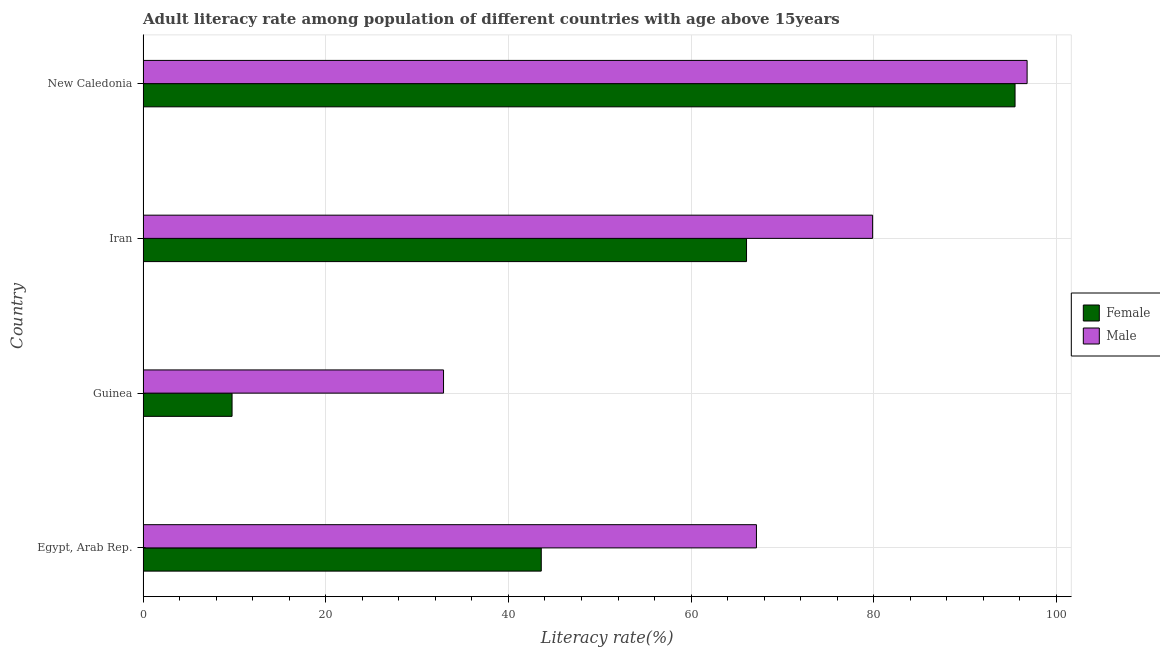How many different coloured bars are there?
Offer a terse response. 2. How many groups of bars are there?
Provide a short and direct response. 4. Are the number of bars on each tick of the Y-axis equal?
Your response must be concise. Yes. What is the label of the 1st group of bars from the top?
Offer a terse response. New Caledonia. What is the female adult literacy rate in Egypt, Arab Rep.?
Provide a succinct answer. 43.6. Across all countries, what is the maximum female adult literacy rate?
Offer a terse response. 95.47. Across all countries, what is the minimum female adult literacy rate?
Your answer should be compact. 9.74. In which country was the female adult literacy rate maximum?
Keep it short and to the point. New Caledonia. In which country was the female adult literacy rate minimum?
Provide a short and direct response. Guinea. What is the total female adult literacy rate in the graph?
Your response must be concise. 214.87. What is the difference between the male adult literacy rate in Guinea and that in New Caledonia?
Provide a succinct answer. -63.89. What is the difference between the male adult literacy rate in Iran and the female adult literacy rate in New Caledonia?
Ensure brevity in your answer.  -15.59. What is the average female adult literacy rate per country?
Your response must be concise. 53.72. What is the difference between the female adult literacy rate and male adult literacy rate in Guinea?
Offer a very short reply. -23.15. What is the ratio of the female adult literacy rate in Egypt, Arab Rep. to that in New Caledonia?
Provide a short and direct response. 0.46. Is the difference between the male adult literacy rate in Guinea and New Caledonia greater than the difference between the female adult literacy rate in Guinea and New Caledonia?
Offer a terse response. Yes. What is the difference between the highest and the second highest male adult literacy rate?
Offer a terse response. 16.91. What is the difference between the highest and the lowest male adult literacy rate?
Make the answer very short. 63.89. In how many countries, is the male adult literacy rate greater than the average male adult literacy rate taken over all countries?
Your answer should be compact. 2. What does the 1st bar from the top in Guinea represents?
Your answer should be compact. Male. How many bars are there?
Ensure brevity in your answer.  8. What is the difference between two consecutive major ticks on the X-axis?
Your response must be concise. 20. Does the graph contain any zero values?
Ensure brevity in your answer.  No. Does the graph contain grids?
Your response must be concise. Yes. What is the title of the graph?
Your response must be concise. Adult literacy rate among population of different countries with age above 15years. What is the label or title of the X-axis?
Offer a terse response. Literacy rate(%). What is the Literacy rate(%) in Female in Egypt, Arab Rep.?
Offer a terse response. 43.6. What is the Literacy rate(%) of Male in Egypt, Arab Rep.?
Keep it short and to the point. 67.15. What is the Literacy rate(%) of Female in Guinea?
Offer a very short reply. 9.74. What is the Literacy rate(%) of Male in Guinea?
Provide a succinct answer. 32.9. What is the Literacy rate(%) in Female in Iran?
Your answer should be very brief. 66.07. What is the Literacy rate(%) in Male in Iran?
Give a very brief answer. 79.87. What is the Literacy rate(%) in Female in New Caledonia?
Give a very brief answer. 95.47. What is the Literacy rate(%) in Male in New Caledonia?
Provide a succinct answer. 96.78. Across all countries, what is the maximum Literacy rate(%) in Female?
Your response must be concise. 95.47. Across all countries, what is the maximum Literacy rate(%) in Male?
Ensure brevity in your answer.  96.78. Across all countries, what is the minimum Literacy rate(%) of Female?
Provide a short and direct response. 9.74. Across all countries, what is the minimum Literacy rate(%) of Male?
Provide a succinct answer. 32.9. What is the total Literacy rate(%) of Female in the graph?
Offer a very short reply. 214.87. What is the total Literacy rate(%) of Male in the graph?
Offer a very short reply. 276.7. What is the difference between the Literacy rate(%) of Female in Egypt, Arab Rep. and that in Guinea?
Offer a very short reply. 33.85. What is the difference between the Literacy rate(%) in Male in Egypt, Arab Rep. and that in Guinea?
Your response must be concise. 34.26. What is the difference between the Literacy rate(%) of Female in Egypt, Arab Rep. and that in Iran?
Give a very brief answer. -22.47. What is the difference between the Literacy rate(%) in Male in Egypt, Arab Rep. and that in Iran?
Provide a short and direct response. -12.72. What is the difference between the Literacy rate(%) in Female in Egypt, Arab Rep. and that in New Caledonia?
Ensure brevity in your answer.  -51.87. What is the difference between the Literacy rate(%) in Male in Egypt, Arab Rep. and that in New Caledonia?
Make the answer very short. -29.63. What is the difference between the Literacy rate(%) of Female in Guinea and that in Iran?
Provide a succinct answer. -56.32. What is the difference between the Literacy rate(%) in Male in Guinea and that in Iran?
Keep it short and to the point. -46.98. What is the difference between the Literacy rate(%) in Female in Guinea and that in New Caledonia?
Give a very brief answer. -85.72. What is the difference between the Literacy rate(%) in Male in Guinea and that in New Caledonia?
Provide a succinct answer. -63.89. What is the difference between the Literacy rate(%) in Female in Iran and that in New Caledonia?
Provide a short and direct response. -29.4. What is the difference between the Literacy rate(%) in Male in Iran and that in New Caledonia?
Your answer should be very brief. -16.91. What is the difference between the Literacy rate(%) in Female in Egypt, Arab Rep. and the Literacy rate(%) in Male in Guinea?
Make the answer very short. 10.7. What is the difference between the Literacy rate(%) of Female in Egypt, Arab Rep. and the Literacy rate(%) of Male in Iran?
Offer a terse response. -36.28. What is the difference between the Literacy rate(%) of Female in Egypt, Arab Rep. and the Literacy rate(%) of Male in New Caledonia?
Ensure brevity in your answer.  -53.19. What is the difference between the Literacy rate(%) in Female in Guinea and the Literacy rate(%) in Male in Iran?
Give a very brief answer. -70.13. What is the difference between the Literacy rate(%) in Female in Guinea and the Literacy rate(%) in Male in New Caledonia?
Give a very brief answer. -87.04. What is the difference between the Literacy rate(%) in Female in Iran and the Literacy rate(%) in Male in New Caledonia?
Give a very brief answer. -30.72. What is the average Literacy rate(%) in Female per country?
Offer a terse response. 53.72. What is the average Literacy rate(%) of Male per country?
Your answer should be compact. 69.18. What is the difference between the Literacy rate(%) of Female and Literacy rate(%) of Male in Egypt, Arab Rep.?
Your answer should be compact. -23.56. What is the difference between the Literacy rate(%) of Female and Literacy rate(%) of Male in Guinea?
Your answer should be compact. -23.15. What is the difference between the Literacy rate(%) of Female and Literacy rate(%) of Male in Iran?
Offer a terse response. -13.8. What is the difference between the Literacy rate(%) in Female and Literacy rate(%) in Male in New Caledonia?
Offer a very short reply. -1.32. What is the ratio of the Literacy rate(%) of Female in Egypt, Arab Rep. to that in Guinea?
Give a very brief answer. 4.47. What is the ratio of the Literacy rate(%) in Male in Egypt, Arab Rep. to that in Guinea?
Make the answer very short. 2.04. What is the ratio of the Literacy rate(%) of Female in Egypt, Arab Rep. to that in Iran?
Offer a very short reply. 0.66. What is the ratio of the Literacy rate(%) in Male in Egypt, Arab Rep. to that in Iran?
Make the answer very short. 0.84. What is the ratio of the Literacy rate(%) in Female in Egypt, Arab Rep. to that in New Caledonia?
Your answer should be compact. 0.46. What is the ratio of the Literacy rate(%) in Male in Egypt, Arab Rep. to that in New Caledonia?
Keep it short and to the point. 0.69. What is the ratio of the Literacy rate(%) of Female in Guinea to that in Iran?
Ensure brevity in your answer.  0.15. What is the ratio of the Literacy rate(%) of Male in Guinea to that in Iran?
Give a very brief answer. 0.41. What is the ratio of the Literacy rate(%) of Female in Guinea to that in New Caledonia?
Your answer should be very brief. 0.1. What is the ratio of the Literacy rate(%) in Male in Guinea to that in New Caledonia?
Offer a very short reply. 0.34. What is the ratio of the Literacy rate(%) in Female in Iran to that in New Caledonia?
Offer a very short reply. 0.69. What is the ratio of the Literacy rate(%) of Male in Iran to that in New Caledonia?
Your answer should be compact. 0.83. What is the difference between the highest and the second highest Literacy rate(%) in Female?
Offer a terse response. 29.4. What is the difference between the highest and the second highest Literacy rate(%) of Male?
Provide a short and direct response. 16.91. What is the difference between the highest and the lowest Literacy rate(%) of Female?
Give a very brief answer. 85.72. What is the difference between the highest and the lowest Literacy rate(%) in Male?
Your response must be concise. 63.89. 